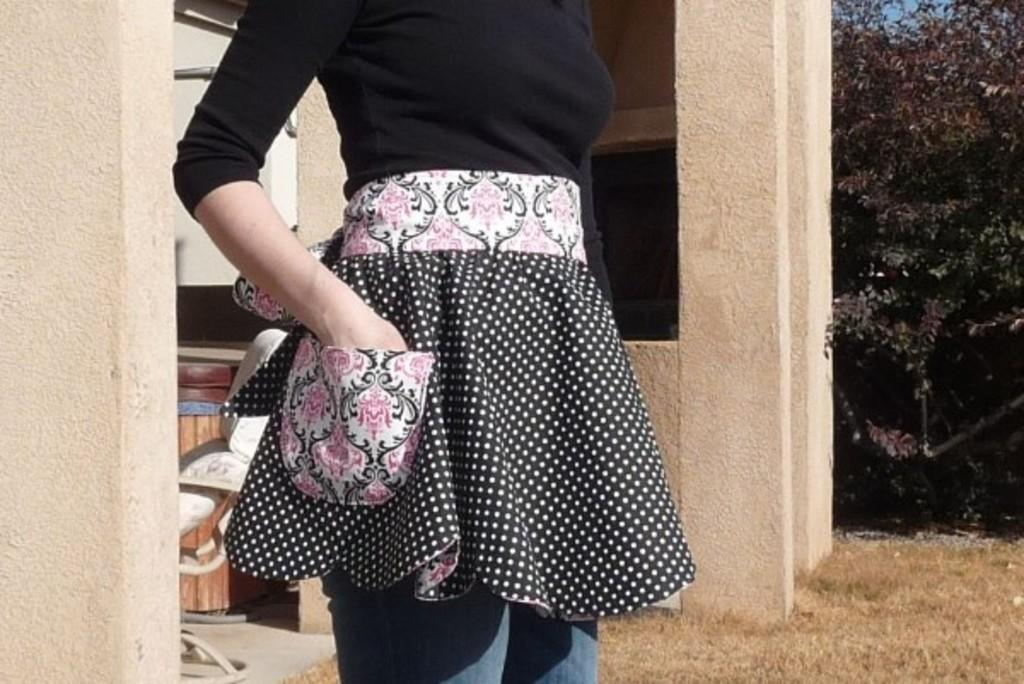Who is the main subject in the image? There is a woman in the middle of the image. What can be seen in the background of the image? There are pillars in the background of the image. What type of vegetation is on the right side of the image? There are trees on the right side of the image. Where is the shelf located in the image? There is no shelf present in the image. What type of bubble can be seen floating near the woman? There is no bubble present in the image. 